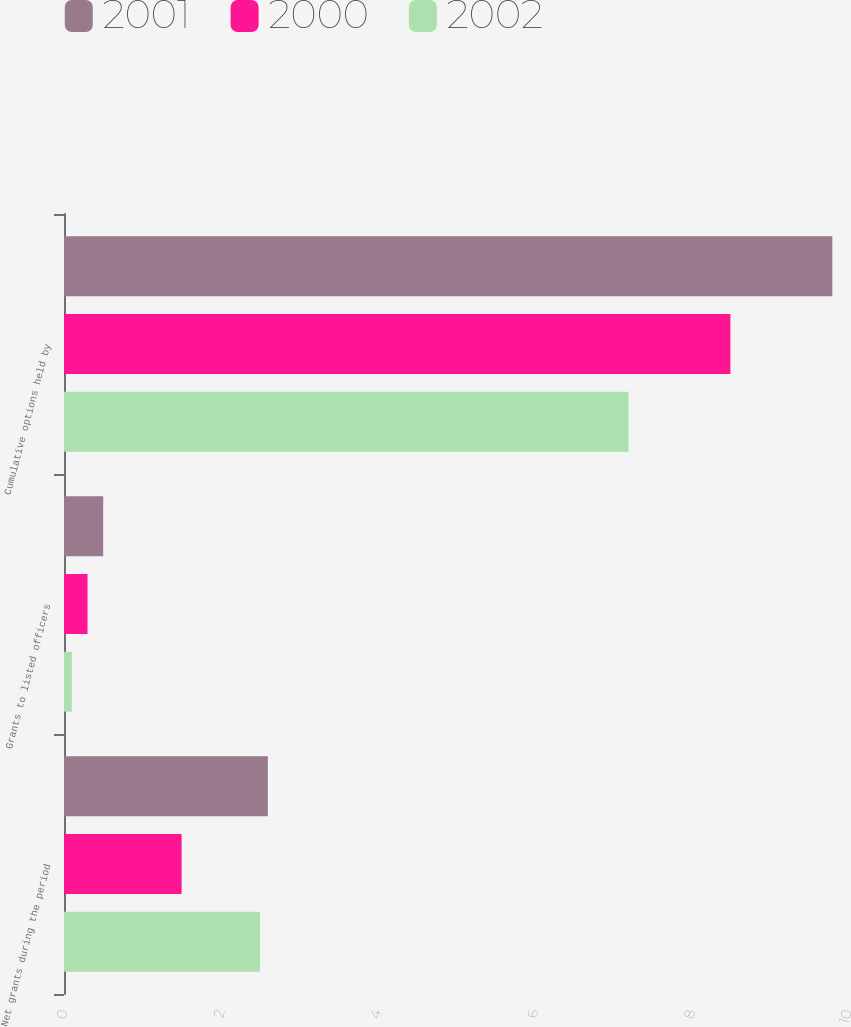Convert chart to OTSL. <chart><loc_0><loc_0><loc_500><loc_500><stacked_bar_chart><ecel><fcel>Net grants during the period<fcel>Grants to listed officers<fcel>Cumulative options held by<nl><fcel>2001<fcel>2.6<fcel>0.5<fcel>9.8<nl><fcel>2000<fcel>1.5<fcel>0.3<fcel>8.5<nl><fcel>2002<fcel>2.5<fcel>0.1<fcel>7.2<nl></chart> 